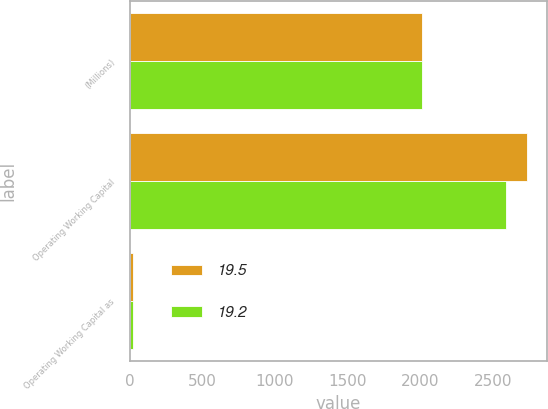Convert chart to OTSL. <chart><loc_0><loc_0><loc_500><loc_500><stacked_bar_chart><ecel><fcel>(Millions)<fcel>Operating Working Capital<fcel>Operating Working Capital as<nl><fcel>19.5<fcel>2011<fcel>2739<fcel>19.5<nl><fcel>19.2<fcel>2010<fcel>2595<fcel>19.2<nl></chart> 